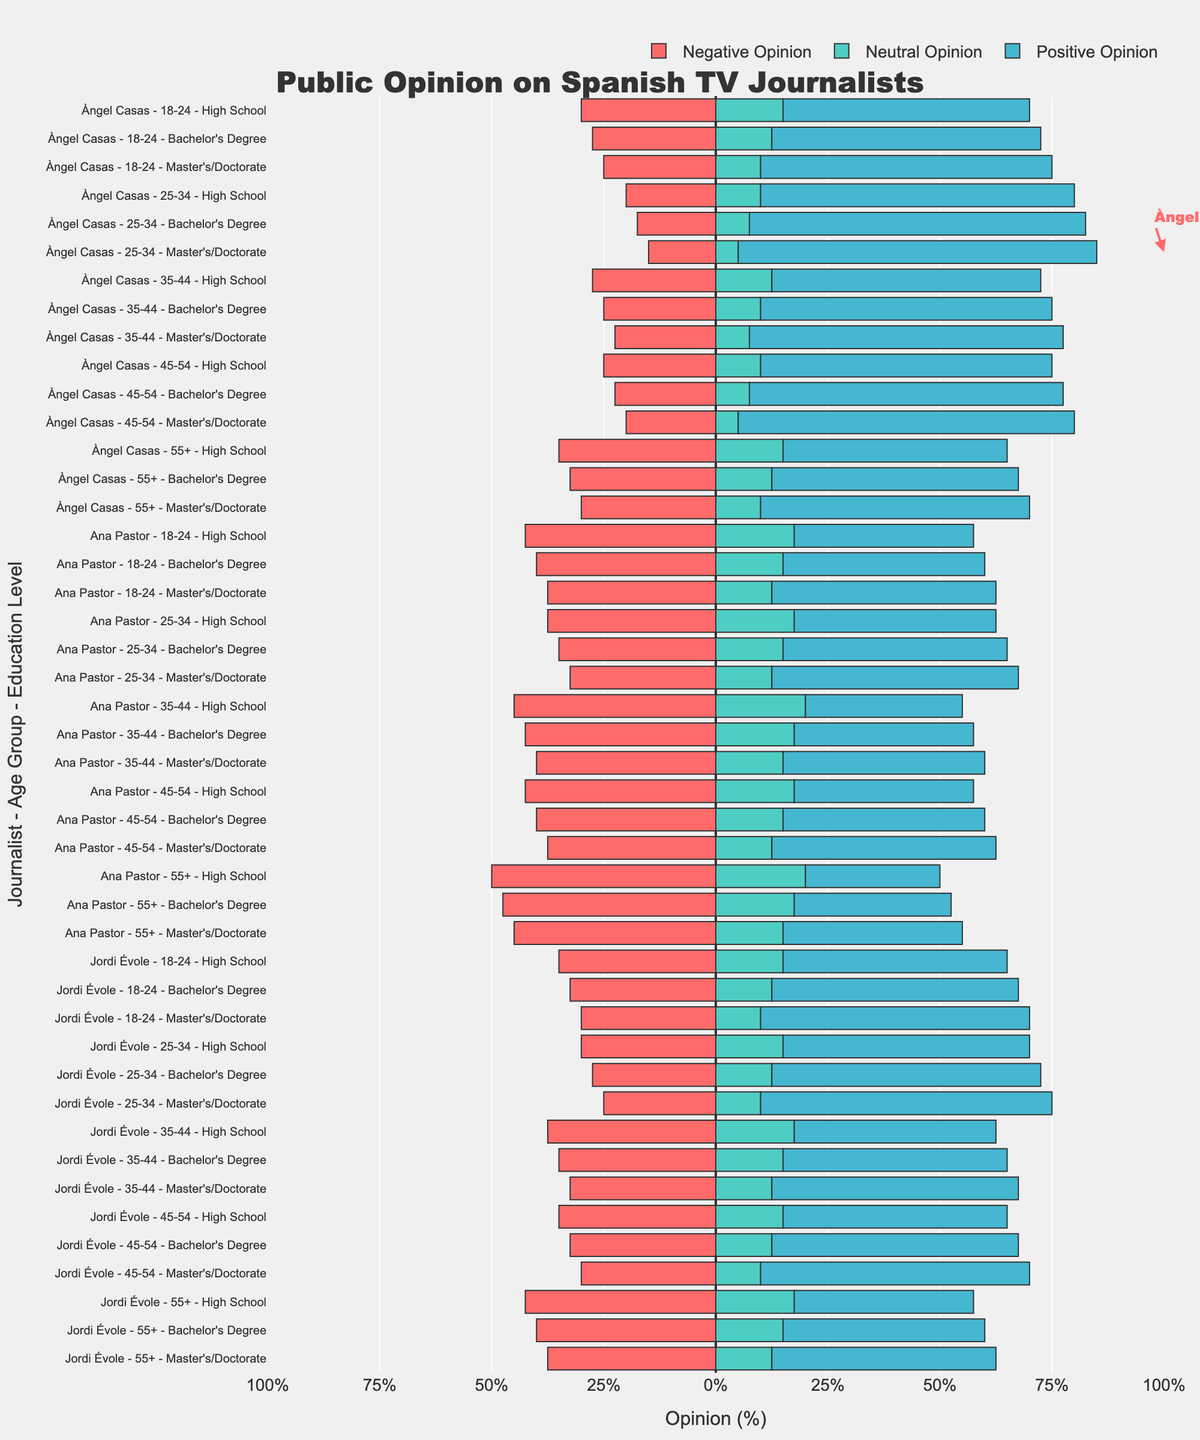What's the highest positive opinion percentage for Àngel Casas across all age groups and education levels? The figure highlights Àngel Casas's highest approval with an annotation. The highest value is specifically pointed out in red color.
Answer: 80% Compare the negative opinions of Ana Pastor and Jordi Évole for the age group 18-24 with a Master's/Doctorate degree. Who has a higher negative opinion percentage? Look at the horizontal bars representing Ana Pastor and Jordi Évole for the age group 18-24 with a Master's/Doctorate degree. Identify the lengths of the bars shaded in red (negative opinion).
Answer: Ana Pastor For which age group and education level does Àngel Casas receive the lowest positive opinion percentage? By comparing the lengths of the green bars representing positive opinions for Àngel Casas across different age groups and education levels, identify the shortest bar.
Answer: 55+, High School What is the sum of neutral opinions across all age groups and education levels for the journalist Àngel Casas? For Àngel Casas, add the neutral opinion percentages from each age group and education level provided in the plot.
Answer: 20 + 15 + 10 + 10 + 15 + 10 + 30 + 25 + 20 = 165% Compare the positive opinions for the age group 25-34 with a Bachelor's Degree between Àngel Casas and Ana Pastor. Who has a higher positive opinion percentage? Look at the horizontal bars representing positive opinions for Àngel Casas and Ana Pastor in the age group 25-34 with a Bachelor's Degree. Compare their lengths.
Answer: Àngel Casas Are there any age groups or education levels where Àngel Casas has less than or equal to 50% positive opinion percentage? If yes, identify them. Check each bar representing Àngel Casas across different age groups and education levels. Evaluate if any green bar (positive opinion) is at or below the 50% mark.
Answer: Yes, 55+, High School Which journalist has the highest neutral opinion percentage for the age group 35-44 with a Bachelor's Degree? Compare the lengths of the gray bars representing neutral opinions for each journalist in the age group 35-44 with a Bachelor's Degree. Identify the longest bar.
Answer: Ana Pastor 